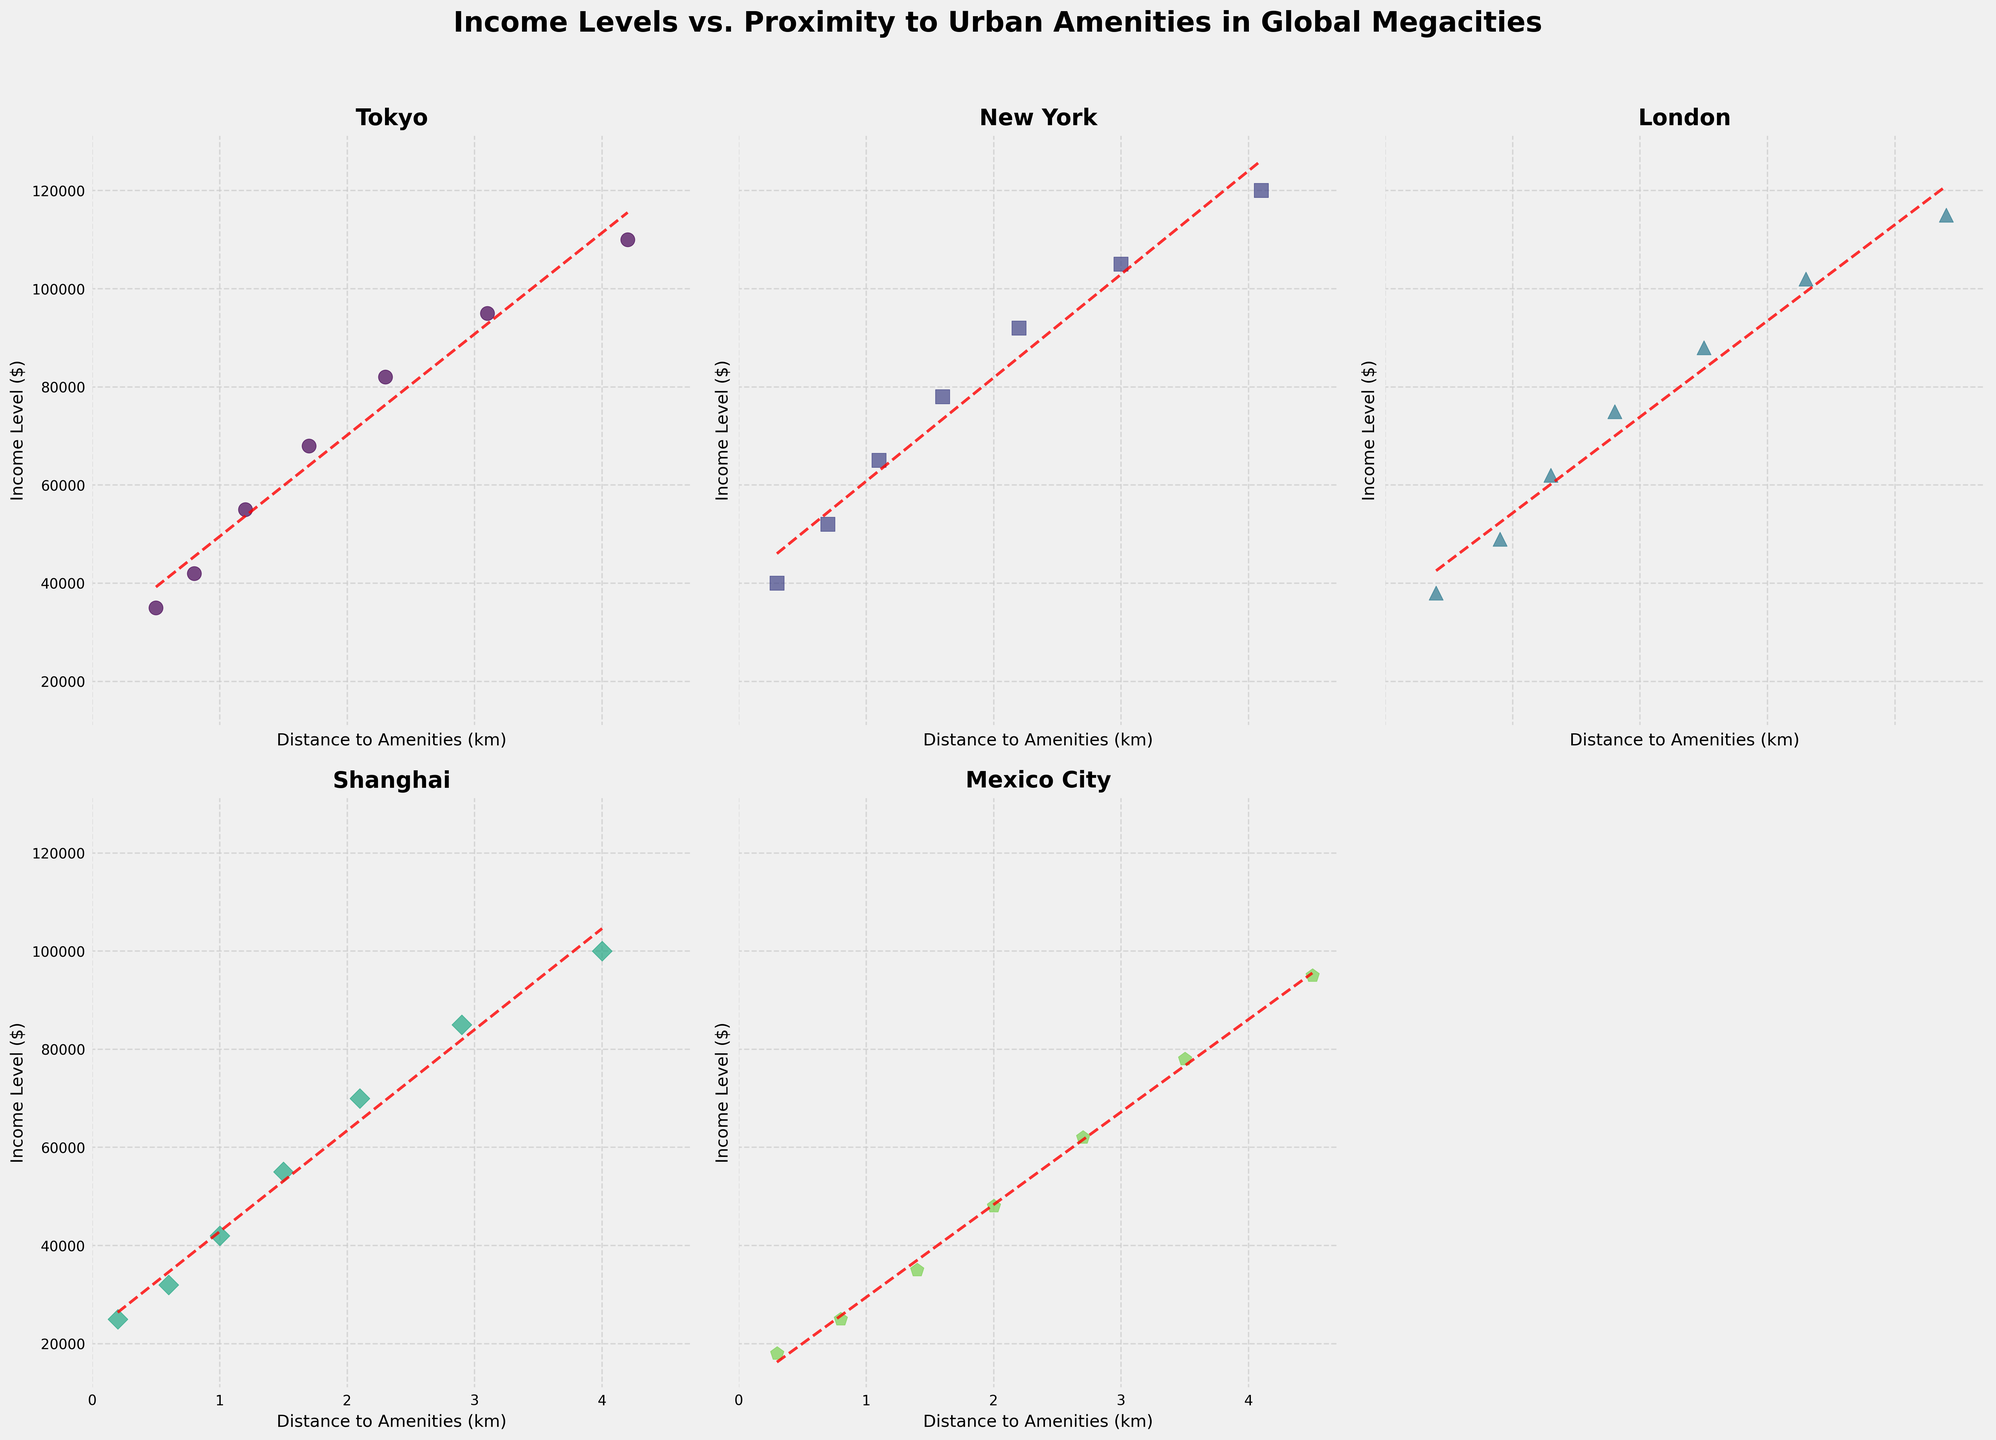what's the average income level for London? The income levels for London are (38000, 49000, 62000, 75000, 88000, 102000, 115000). Sum them up to get 519000, divide by 7 to find the average: 519000 / 7
Answer: 74142.86 which city has the highest income level at the closest distance to amenities? The closest distances and corresponding income levels are: Tokyo (35000), New York (40000), London (38000), Shanghai (25000), Mexico City (18000), Mumbai (12000). New York has the highest income level at the closest distance.
Answer: New York what's the difference in income levels between Mumbai and Tokyo at 1.4 km distance to amenities? For Mumbai, the income level is 40000 at 1.4 km. For Tokyo, it's 68000 at 1.7 km, the closest distance listed. Difference: 68000 - 40000
Answer: 28000 which city shows the steepest increase in income level with distance to amenities? This requires comparing the trend lines' slopes visually. The trend line in Shanghai appears to rise sharply.
Answer: Shanghai how do the income levels in Mexico City compare across the distance to amenities? Visually, income levels rise steadily from 18000 to 95000 as distance increases from 0.3 to 4.5 km.
Answer: Steadily increasing 